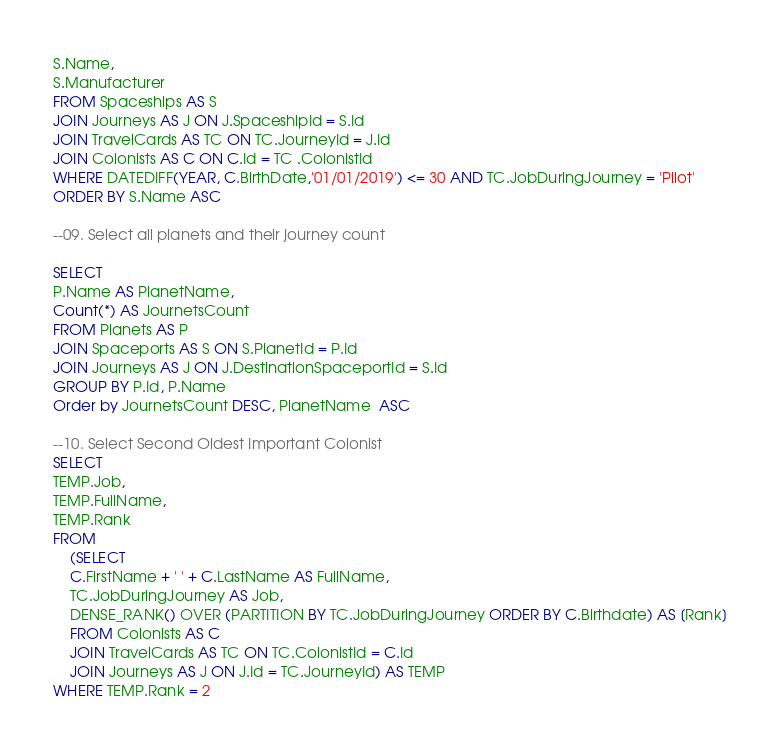Convert code to text. <code><loc_0><loc_0><loc_500><loc_500><_SQL_>S.Name,
S.Manufacturer
FROM Spaceships AS S
JOIN Journeys AS J ON J.SpaceshipId = S.Id
JOIN TravelCards AS TC ON TC.JourneyId = J.Id
JOIN Colonists AS C ON C.Id = TC .ColonistId
WHERE DATEDIFF(YEAR, C.BirthDate,'01/01/2019') <= 30 AND TC.JobDuringJourney = 'Pilot'
ORDER BY S.Name ASC

--09. Select all planets and their journey count

SELECT 
P.Name AS PlanetName,
Count(*) AS JournetsCount
FROM Planets AS P
JOIN Spaceports AS S ON S.PlanetId = P.Id
JOIN Journeys AS J ON J.DestinationSpaceportId = S.Id
GROUP BY P.Id, P.Name
Order by JournetsCount DESC, PlanetName  ASC

--10. Select Second Oldest Important Colonist
SELECT 
TEMP.Job,
TEMP.FullName,
TEMP.Rank
FROM
	(SELECT 
	C.FirstName + ' ' + C.LastName AS FullName,
	TC.JobDuringJourney AS Job,
	DENSE_RANK() OVER (PARTITION BY TC.JobDuringJourney ORDER BY C.Birthdate) AS [Rank]
	FROM Colonists AS C
	JOIN TravelCards AS TC ON TC.ColonistId = C.Id
	JOIN Journeys AS J ON J.Id = TC.JourneyId) AS TEMP
WHERE TEMP.Rank = 2</code> 